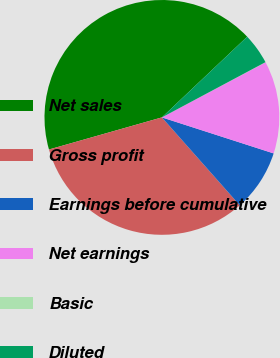<chart> <loc_0><loc_0><loc_500><loc_500><pie_chart><fcel>Net sales<fcel>Gross profit<fcel>Earnings before cumulative<fcel>Net earnings<fcel>Basic<fcel>Diluted<nl><fcel>42.35%<fcel>32.13%<fcel>8.5%<fcel>12.73%<fcel>0.03%<fcel>4.26%<nl></chart> 